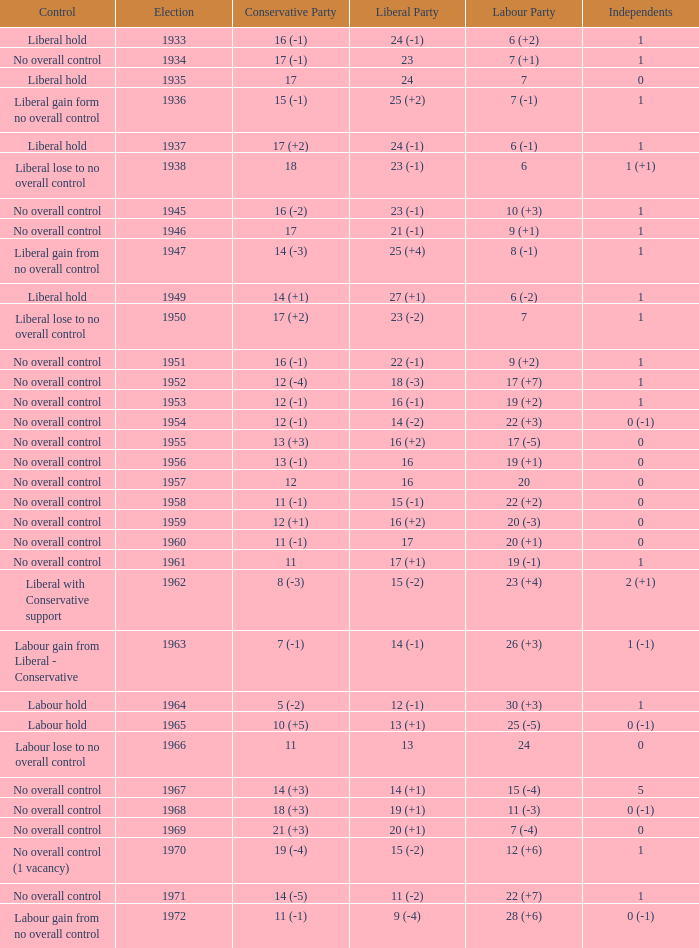What was the Liberal Party result from the election having a Conservative Party result of 16 (-1) and Labour of 6 (+2)? 24 (-1). 